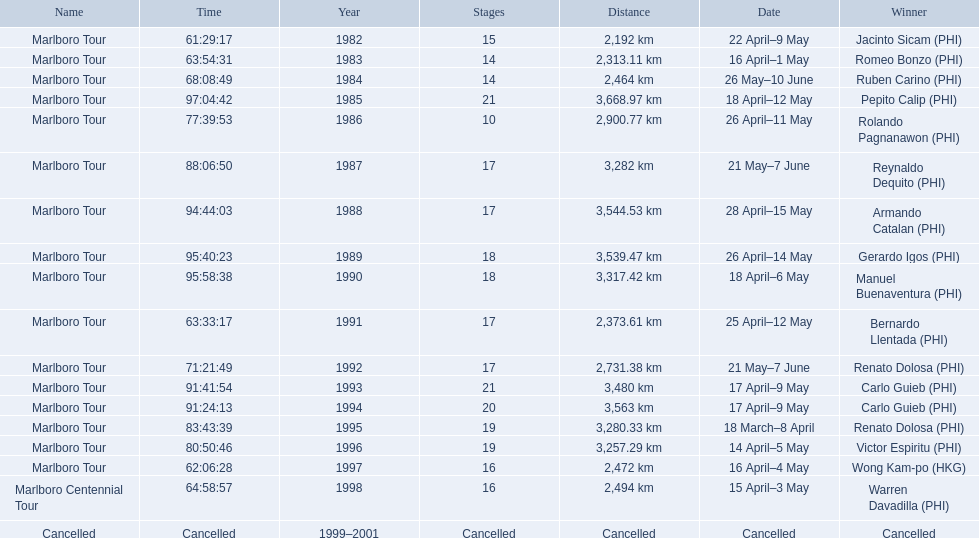What were the tour names during le tour de filipinas? Marlboro Tour, Marlboro Tour, Marlboro Tour, Marlboro Tour, Marlboro Tour, Marlboro Tour, Marlboro Tour, Marlboro Tour, Marlboro Tour, Marlboro Tour, Marlboro Tour, Marlboro Tour, Marlboro Tour, Marlboro Tour, Marlboro Tour, Marlboro Tour, Marlboro Centennial Tour, Cancelled. What were the recorded distances for each marlboro tour? 2,192 km, 2,313.11 km, 2,464 km, 3,668.97 km, 2,900.77 km, 3,282 km, 3,544.53 km, 3,539.47 km, 3,317.42 km, 2,373.61 km, 2,731.38 km, 3,480 km, 3,563 km, 3,280.33 km, 3,257.29 km, 2,472 km. And of those distances, which was the longest? 3,668.97 km. 